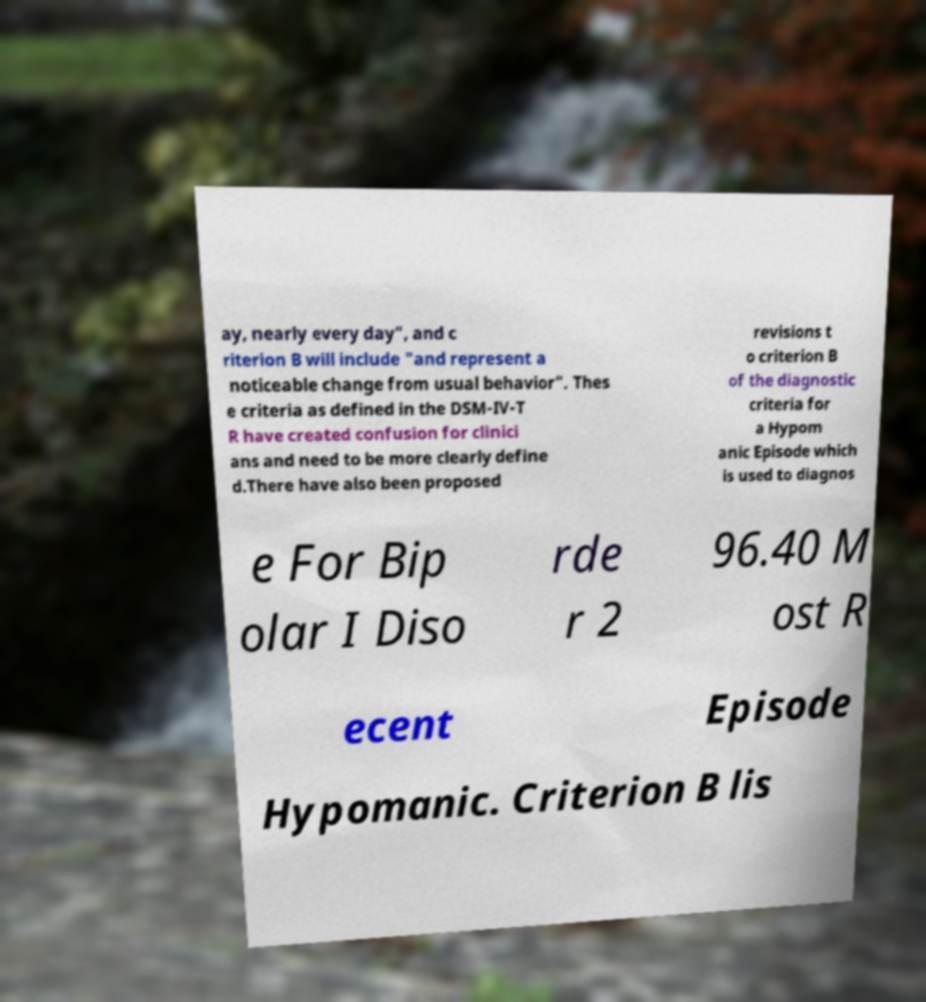Can you accurately transcribe the text from the provided image for me? ay, nearly every day", and c riterion B will include "and represent a noticeable change from usual behavior". Thes e criteria as defined in the DSM-IV-T R have created confusion for clinici ans and need to be more clearly define d.There have also been proposed revisions t o criterion B of the diagnostic criteria for a Hypom anic Episode which is used to diagnos e For Bip olar I Diso rde r 2 96.40 M ost R ecent Episode Hypomanic. Criterion B lis 